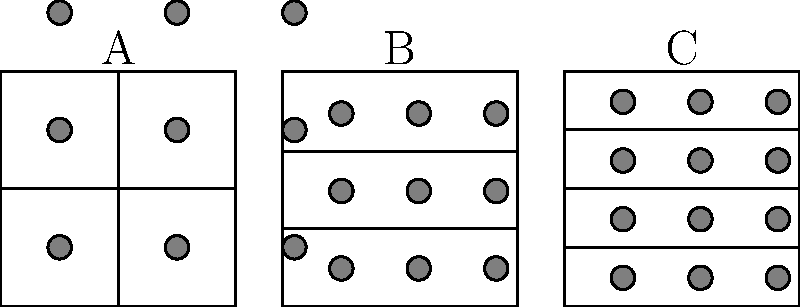Which of the three interface layouts (A, B, or C) is likely to be the most user-friendly for a mobile application, considering the principles of visual hierarchy and ease of interaction? To determine the most user-friendly layout, we need to consider several UX design principles:

1. Visual Hierarchy: A clear visual hierarchy helps users understand the importance and relationship between elements.

2. Ease of Interaction: The layout should accommodate easy thumb reach on mobile devices.

3. Consistency: A consistent grid system improves usability and aesthetics.

4. Simplicity: Simpler layouts are often easier to understand and use.

Analyzing each layout:

A. This layout divides the screen into four equal quadrants. While simple, it may not provide enough flexibility for various content types and could lead to awkward empty spaces.

B. This layout divides the screen into three equal horizontal sections. It offers more flexibility than A and aligns well with the natural top-to-bottom reading pattern. The three-section layout is commonly used in mobile apps for its balance between simplicity and functionality.

C. This layout divides the screen into four horizontal sections. While it offers the most divisions, it may lead to overcrowding on smaller screens and could make elements too small for comfortable touch interaction.

Considering these factors, Layout B is likely to be the most user-friendly:
- It provides a clear visual hierarchy (top, middle, bottom).
- It allows for easy thumb reach to all sections on most mobile devices.
- It offers a consistent and simple grid system.
- It provides enough flexibility for various content types without overcrowding.
Answer: B 